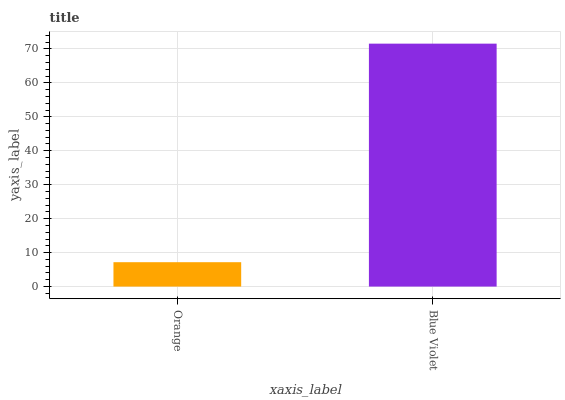Is Blue Violet the minimum?
Answer yes or no. No. Is Blue Violet greater than Orange?
Answer yes or no. Yes. Is Orange less than Blue Violet?
Answer yes or no. Yes. Is Orange greater than Blue Violet?
Answer yes or no. No. Is Blue Violet less than Orange?
Answer yes or no. No. Is Blue Violet the high median?
Answer yes or no. Yes. Is Orange the low median?
Answer yes or no. Yes. Is Orange the high median?
Answer yes or no. No. Is Blue Violet the low median?
Answer yes or no. No. 